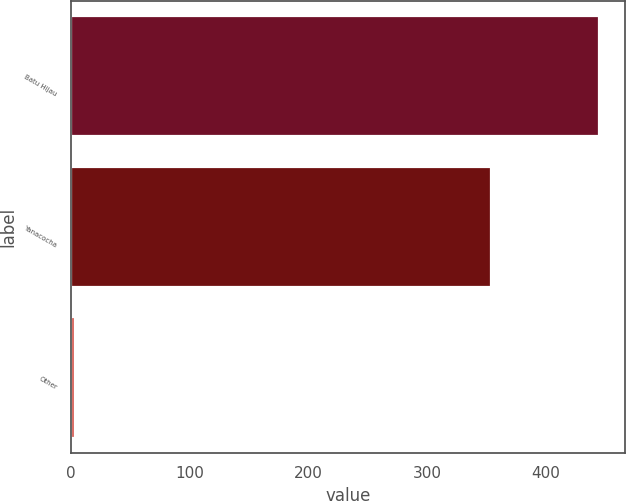<chart> <loc_0><loc_0><loc_500><loc_500><bar_chart><fcel>Batu Hijau<fcel>Yanacocha<fcel>Other<nl><fcel>445<fcel>354<fcel>3<nl></chart> 